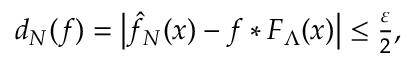<formula> <loc_0><loc_0><loc_500><loc_500>\begin{array} { r } { d _ { N } ( f ) = \left | \hat { f } _ { N } ( x ) - f * F _ { \Lambda } ( x ) \right | \leq \frac { \varepsilon } { 2 } , } \end{array}</formula> 